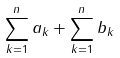<formula> <loc_0><loc_0><loc_500><loc_500>\sum _ { k = 1 } ^ { n } a _ { k } + \sum _ { k = 1 } ^ { n } b _ { k }</formula> 